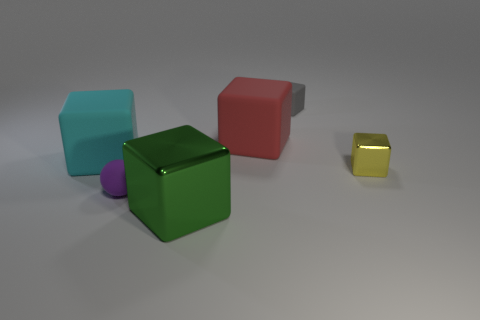Subtract all big metallic blocks. How many blocks are left? 4 Add 2 big blocks. How many objects exist? 8 Subtract all green cubes. How many cubes are left? 4 Subtract all balls. How many objects are left? 5 Subtract 1 balls. How many balls are left? 0 Subtract 0 brown cylinders. How many objects are left? 6 Subtract all yellow cubes. Subtract all gray cylinders. How many cubes are left? 4 Subtract all purple cylinders. How many red cubes are left? 1 Subtract all small purple balls. Subtract all small gray shiny cylinders. How many objects are left? 5 Add 1 large red cubes. How many large red cubes are left? 2 